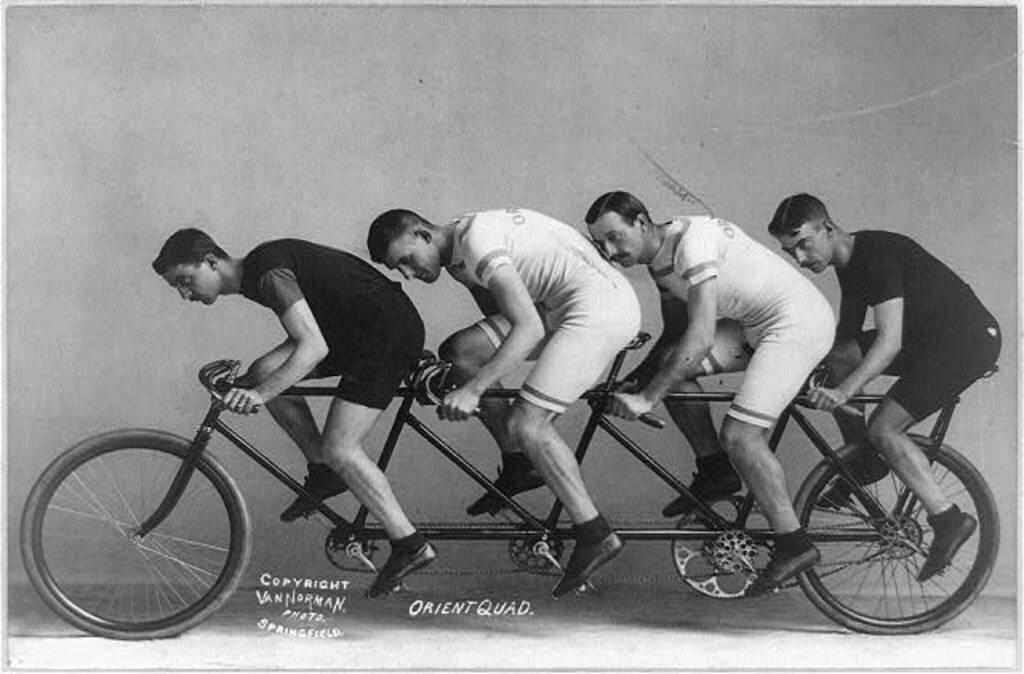What is the main subject of the image? The main subject of the image is a group of men. What are the men in the image doing? The men are cycling a bicycle. What type of floor can be seen beneath the men in the image? There is no reference to a floor in the image, as it features a group of men cycling a bicycle. What type of acoustics can be heard in the image? There is no sound present in the image, so it's not possible to determine the acoustics. Can you see any birds in the image? There is no bird present in the image. 